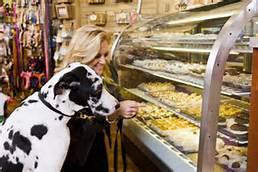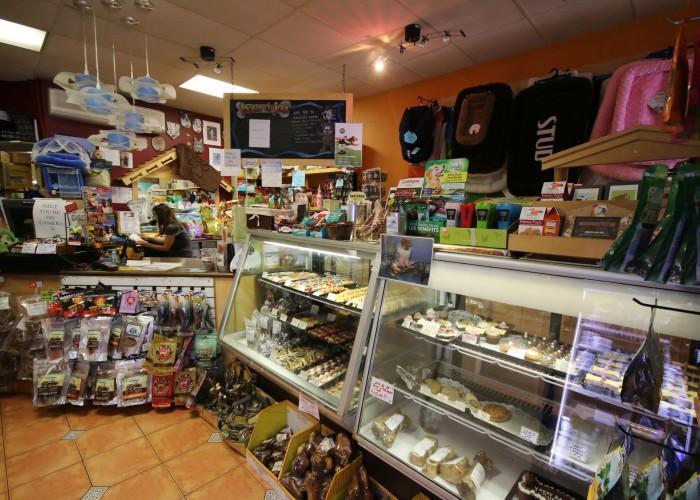The first image is the image on the left, the second image is the image on the right. Analyze the images presented: Is the assertion "A white and black dog is standing near a glass case in one  of the images." valid? Answer yes or no. Yes. 